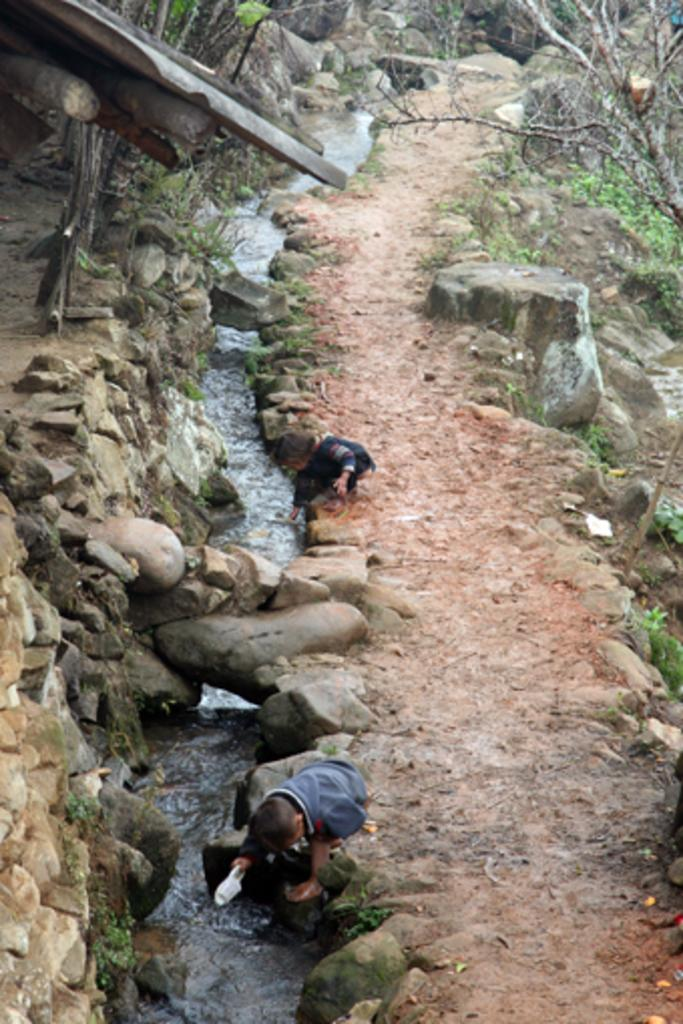How many kids are present in the image? There are two kids sitting in the image. What is in front of the kids? There is a small water canal in front of the kids. What type of terrain is visible in the image? There is soil, rocks, grass, and stones in the image. What can be seen in the background of the image? There are two trees in the background of the image. What color are the eyes of the tree in the image? There are no trees with eyes in the image; trees do not have eyes. 